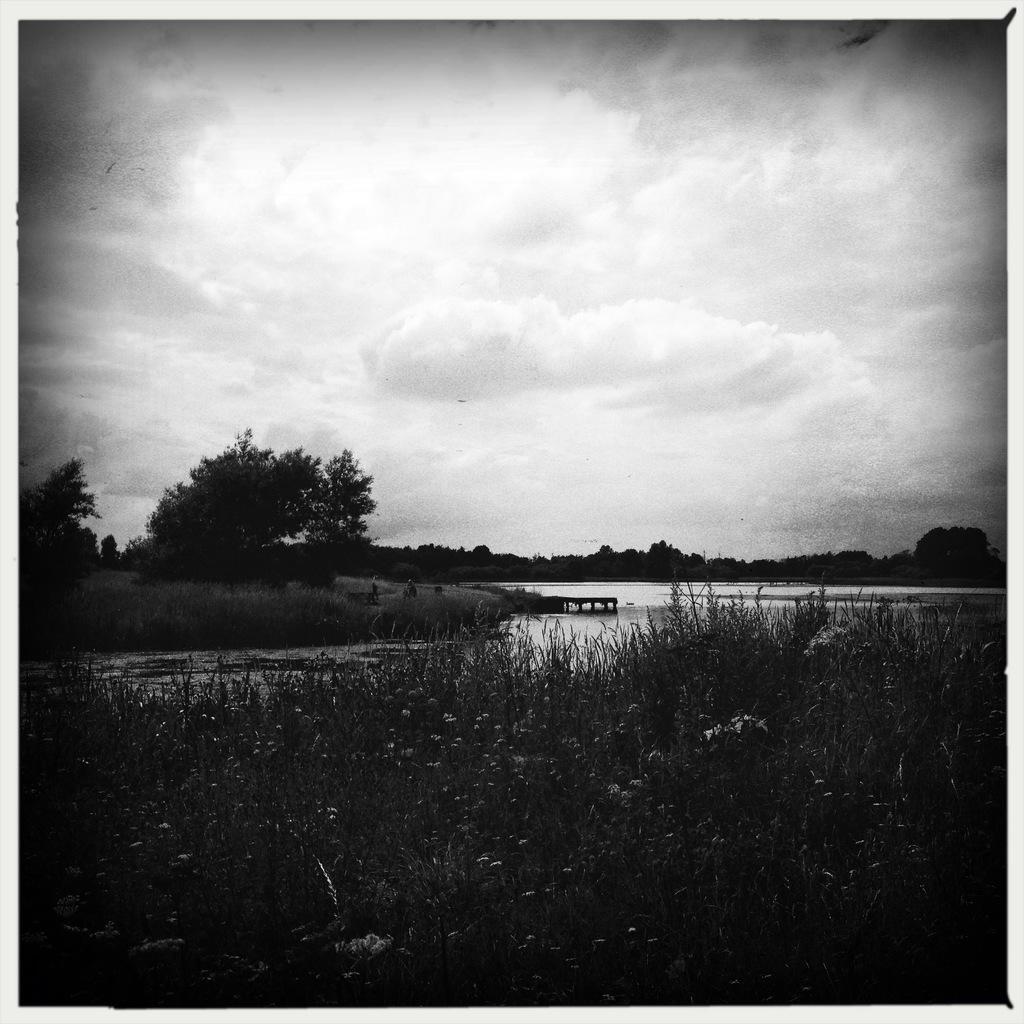Could you give a brief overview of what you see in this image? It is the black and white image in which we can see there is water in the middle. At the bottom there are plants. In the middle there is a ground on the left side. On the ground there are trees. At the top there is the sky. 